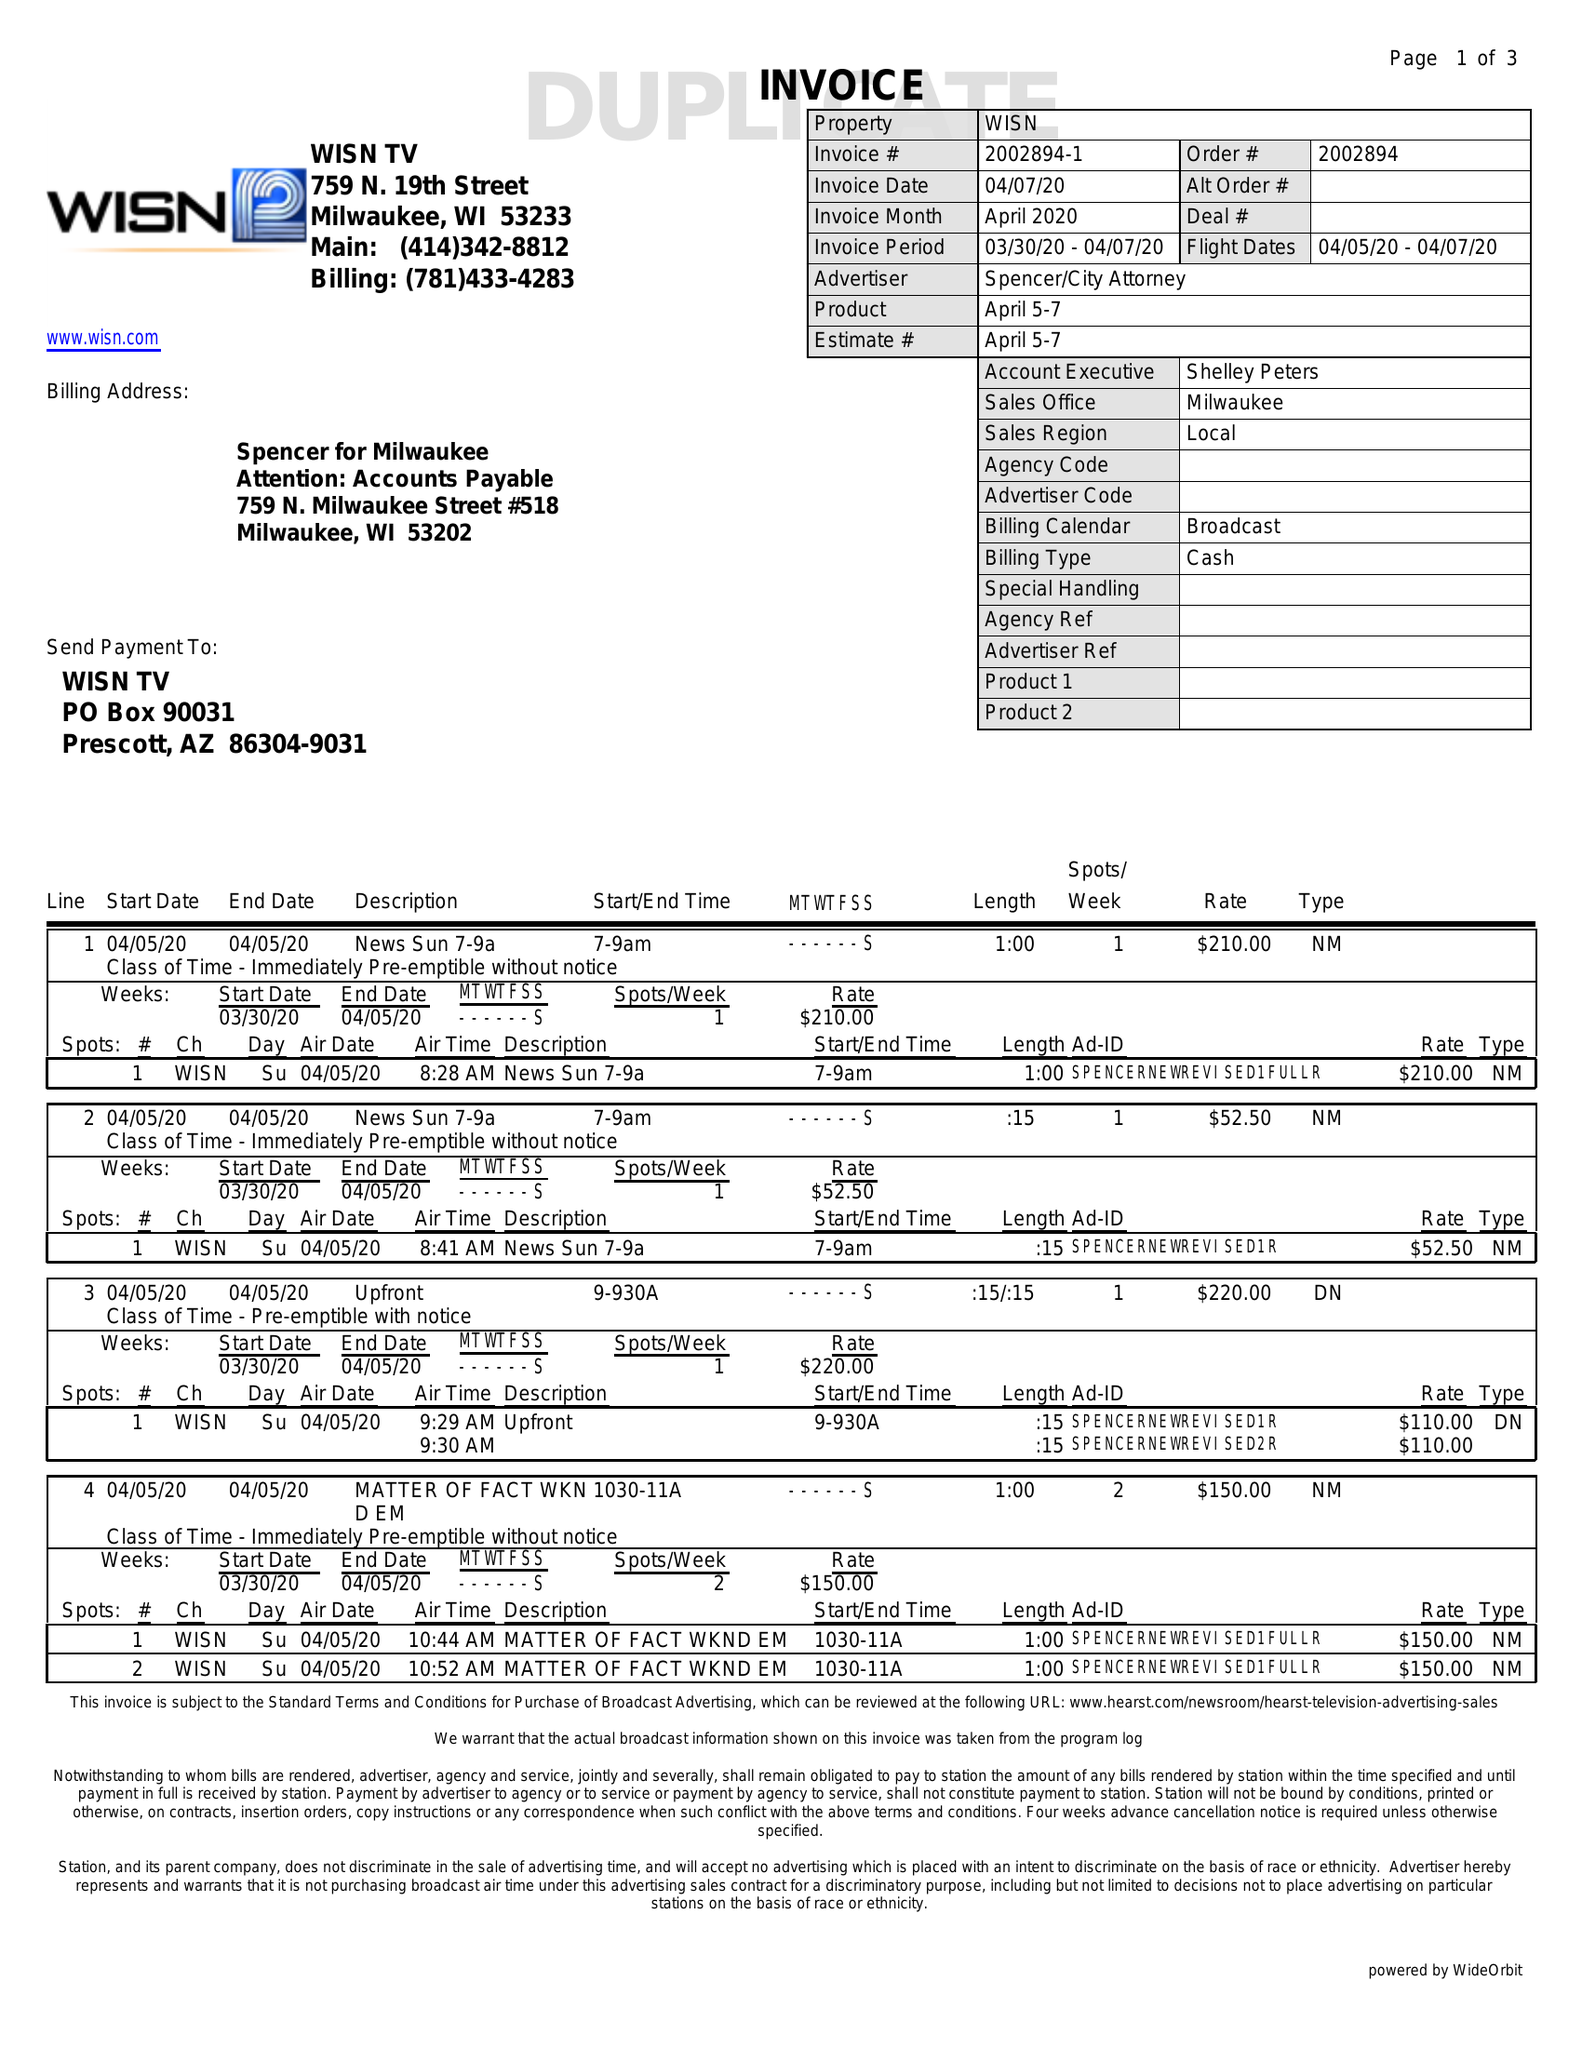What is the value for the advertiser?
Answer the question using a single word or phrase. SPENCER/CITYATTORNEY 